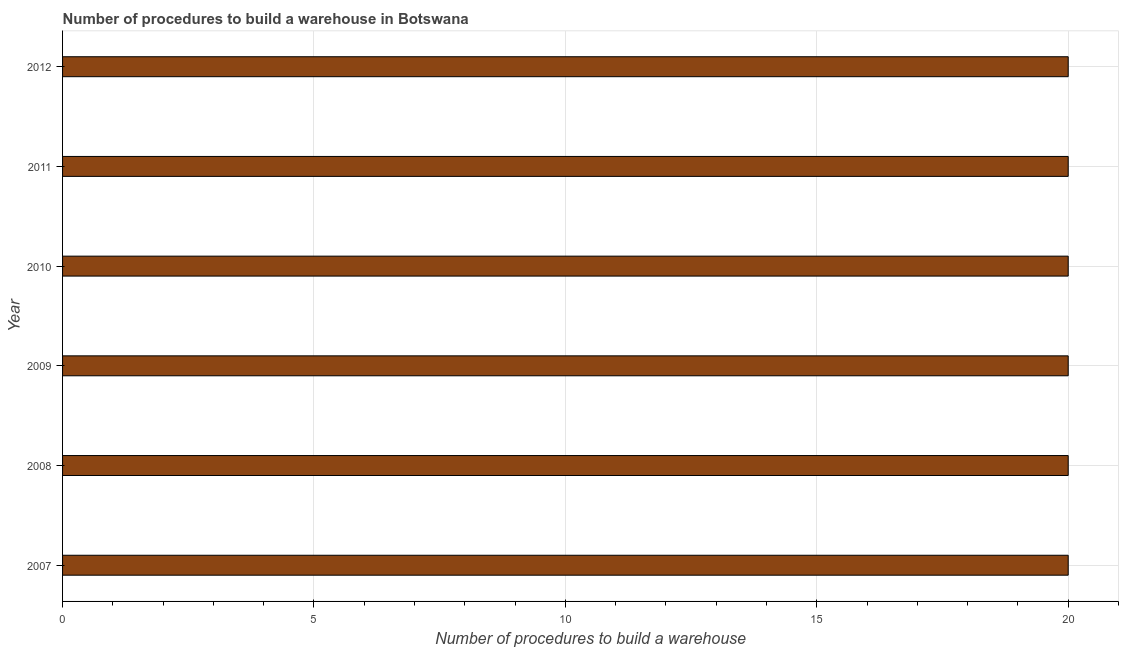What is the title of the graph?
Ensure brevity in your answer.  Number of procedures to build a warehouse in Botswana. What is the label or title of the X-axis?
Your answer should be compact. Number of procedures to build a warehouse. Across all years, what is the maximum number of procedures to build a warehouse?
Give a very brief answer. 20. In which year was the number of procedures to build a warehouse minimum?
Make the answer very short. 2007. What is the sum of the number of procedures to build a warehouse?
Provide a short and direct response. 120. What is the difference between the number of procedures to build a warehouse in 2007 and 2008?
Offer a very short reply. 0. What is the average number of procedures to build a warehouse per year?
Your answer should be compact. 20. What is the ratio of the number of procedures to build a warehouse in 2011 to that in 2012?
Your answer should be compact. 1. Is the number of procedures to build a warehouse in 2009 less than that in 2011?
Offer a terse response. No. Is the difference between the number of procedures to build a warehouse in 2010 and 2011 greater than the difference between any two years?
Provide a short and direct response. Yes. What is the difference between the highest and the second highest number of procedures to build a warehouse?
Make the answer very short. 0. What is the difference between two consecutive major ticks on the X-axis?
Your answer should be very brief. 5. What is the Number of procedures to build a warehouse of 2007?
Offer a terse response. 20. What is the Number of procedures to build a warehouse of 2008?
Offer a very short reply. 20. What is the difference between the Number of procedures to build a warehouse in 2007 and 2009?
Offer a very short reply. 0. What is the difference between the Number of procedures to build a warehouse in 2007 and 2010?
Make the answer very short. 0. What is the difference between the Number of procedures to build a warehouse in 2007 and 2012?
Offer a very short reply. 0. What is the difference between the Number of procedures to build a warehouse in 2008 and 2009?
Your answer should be very brief. 0. What is the difference between the Number of procedures to build a warehouse in 2008 and 2010?
Offer a terse response. 0. What is the difference between the Number of procedures to build a warehouse in 2008 and 2011?
Your response must be concise. 0. What is the difference between the Number of procedures to build a warehouse in 2009 and 2012?
Your response must be concise. 0. What is the difference between the Number of procedures to build a warehouse in 2010 and 2011?
Your response must be concise. 0. What is the difference between the Number of procedures to build a warehouse in 2010 and 2012?
Give a very brief answer. 0. What is the ratio of the Number of procedures to build a warehouse in 2007 to that in 2009?
Your response must be concise. 1. What is the ratio of the Number of procedures to build a warehouse in 2007 to that in 2010?
Your answer should be very brief. 1. What is the ratio of the Number of procedures to build a warehouse in 2007 to that in 2011?
Offer a very short reply. 1. What is the ratio of the Number of procedures to build a warehouse in 2008 to that in 2009?
Provide a succinct answer. 1. What is the ratio of the Number of procedures to build a warehouse in 2009 to that in 2010?
Your answer should be compact. 1. What is the ratio of the Number of procedures to build a warehouse in 2009 to that in 2011?
Your answer should be very brief. 1. What is the ratio of the Number of procedures to build a warehouse in 2009 to that in 2012?
Give a very brief answer. 1. What is the ratio of the Number of procedures to build a warehouse in 2010 to that in 2011?
Your answer should be very brief. 1. What is the ratio of the Number of procedures to build a warehouse in 2010 to that in 2012?
Give a very brief answer. 1. 